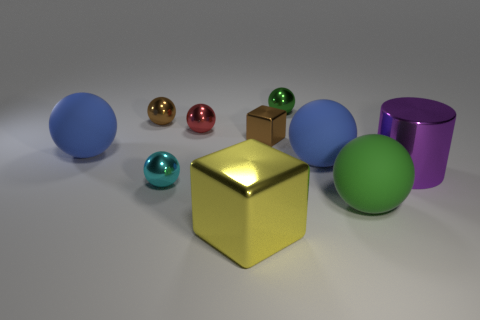Is the number of small red metal balls on the right side of the large purple metallic cylinder less than the number of small spheres left of the red ball?
Provide a succinct answer. Yes. What is the green ball that is in front of the blue rubber sphere to the right of the big blue ball that is on the left side of the brown metal ball made of?
Keep it short and to the point. Rubber. There is a metal thing that is behind the red shiny ball and in front of the tiny green thing; what is its size?
Your answer should be compact. Small. How many blocks are yellow things or cyan metallic objects?
Keep it short and to the point. 1. What is the color of the shiny cylinder that is the same size as the green matte sphere?
Your response must be concise. Purple. Are there any other things that are the same shape as the yellow metal thing?
Provide a succinct answer. Yes. The other tiny object that is the same shape as the yellow metallic thing is what color?
Your answer should be very brief. Brown. What number of things are either green things or rubber objects that are to the left of the yellow object?
Keep it short and to the point. 3. Are there fewer green metal objects that are right of the big green rubber ball than small blue blocks?
Offer a very short reply. No. What size is the green sphere that is in front of the metallic thing right of the big rubber ball in front of the large purple shiny thing?
Provide a succinct answer. Large. 